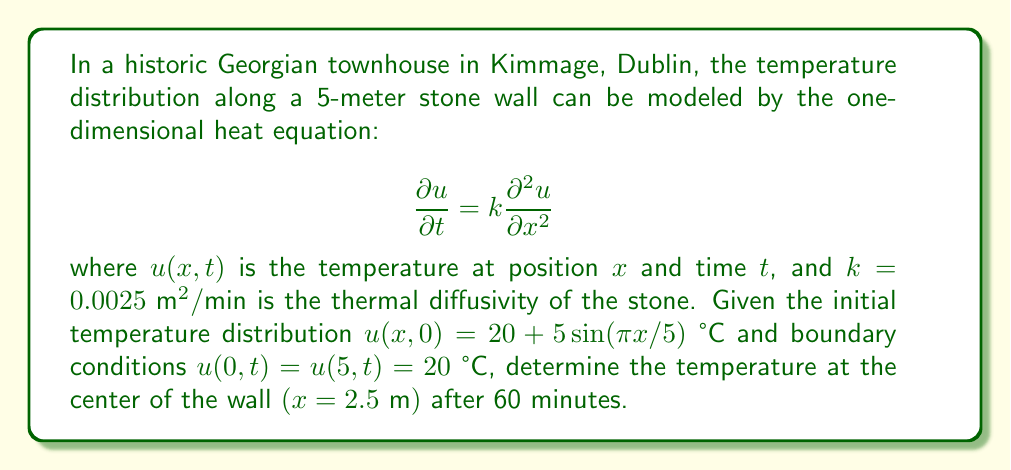Show me your answer to this math problem. To solve this problem, we'll use the method of separation of variables:

1) Assume a solution of the form $u(x,t) = X(x)T(t)$

2) Substituting into the heat equation:
   $$X(x)T'(t) = kX''(x)T(t)$$
   $$\frac{T'(t)}{kT(t)} = \frac{X''(x)}{X(x)} = -\lambda$$

3) This gives us two ordinary differential equations:
   $$T'(t) + k\lambda T(t) = 0$$
   $$X''(x) + \lambda X(x) = 0$$

4) The general solution is:
   $$u(x,t) = \sum_{n=1}^{\infty} A_n \sin(\frac{n\pi x}{L})e^{-k(\frac{n\pi}{L})^2t}$$
   where $L = 5$ is the length of the wall.

5) The initial condition gives:
   $$20 + 5\sin(\frac{\pi x}{5}) = \sum_{n=1}^{\infty} A_n \sin(\frac{n\pi x}{5})$$

6) Comparing coefficients, we see that $A_1 = 5$ and all other $A_n = 0$

7) Therefore, the solution is:
   $$u(x,t) = 20 + 5\sin(\frac{\pi x}{5})e^{-k(\frac{\pi}{5})^2t}$$

8) At $x = 2.5$ and $t = 60$:
   $$u(2.5, 60) = 20 + 5\sin(\frac{\pi}{2})e^{-0.0025(\frac{\pi}{5})^2 60}$$
   $$= 20 + 5e^{-0.0025(\frac{\pi}{5})^2 60}$$

9) Calculating the exponent:
   $$-0.0025(\frac{\pi}{5})^2 60 \approx -0.1896$$

10) Therefore:
    $$u(2.5, 60) \approx 20 + 5e^{-0.1896} \approx 24.14 \text{ °C}$$
Answer: 24.14 °C 